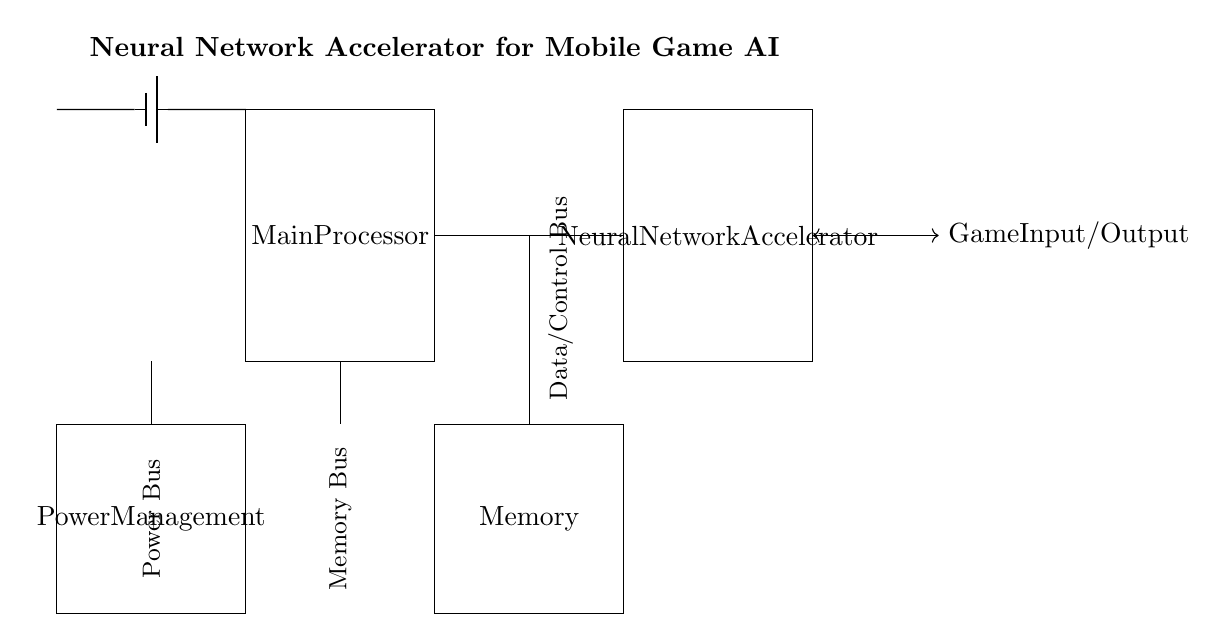What are the main components of the circuit? The circuit diagram contains four main components: Main Processor, Neural Network Accelerator, Memory, and Power Management. Each component is represented as a rectangle with its label inside.
Answer: Main Processor, Neural Network Accelerator, Memory, Power Management What type of connections are indicated in the diagram? The diagram shows several connections between components, including a Data/Control Bus between the Main Processor and Neural Network Accelerator, a Memory Bus to the Memory, and a Power Bus from Power Management. These are represented by lines connecting the components.
Answer: Data/Control Bus, Memory Bus, Power Bus What is the role of the Battery in this circuit? The Battery supplies power to the entire circuit, specifically to the Power Management component. It is indicated at the top left of the diagram, with a connecting line leading to Power Management.
Answer: Power Supply How many distinct buses are depicted in the circuit? The circuit diagram illustrates three distinct buses: Data/Control Bus, Memory Bus, and Power Bus. Each bus connects specific components, reflecting the data flow and power management in the circuit.
Answer: Three Which component receives the game input/output signal? The game input/output signal is received by the Neural Network Accelerator, as indicated by the arrow connecting it to the right side of the component. This shows that it interacts with the external game interface.
Answer: Neural Network Accelerator What is the purpose of the Memory component in relation to the Neural Network Accelerator? The Memory component stores data and parameters used by the Neural Network Accelerator during processing, indicated by the Memory Bus that connects to the Neural Network Accelerator. This enables efficient data retrieval for machine learning tasks.
Answer: Data Storage Where is the Power Management located in the circuit? The Power Management component is located to the left side of the circuit, underneath the Battery. It manages the distribution of power to other components in the circuit.
Answer: Left side 